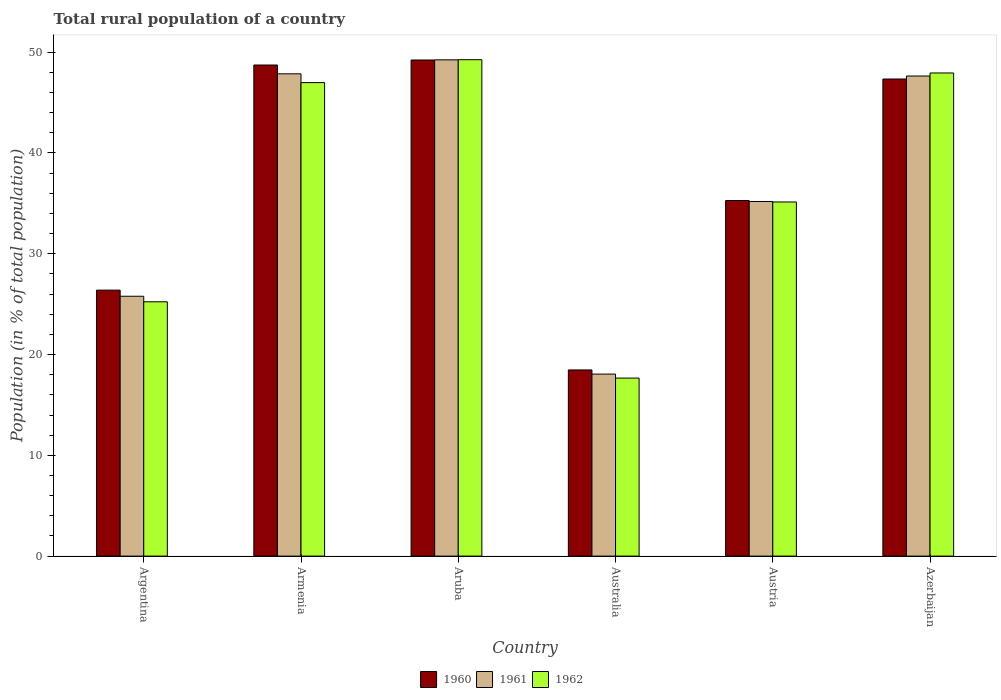How many bars are there on the 3rd tick from the left?
Your answer should be very brief. 3. How many bars are there on the 2nd tick from the right?
Ensure brevity in your answer.  3. What is the label of the 2nd group of bars from the left?
Ensure brevity in your answer.  Armenia. What is the rural population in 1961 in Armenia?
Your answer should be very brief. 47.85. Across all countries, what is the maximum rural population in 1960?
Keep it short and to the point. 49.22. Across all countries, what is the minimum rural population in 1960?
Your response must be concise. 18.47. In which country was the rural population in 1962 maximum?
Your response must be concise. Aruba. In which country was the rural population in 1960 minimum?
Give a very brief answer. Australia. What is the total rural population in 1960 in the graph?
Give a very brief answer. 225.43. What is the difference between the rural population in 1960 in Argentina and that in Australia?
Provide a short and direct response. 7.92. What is the difference between the rural population in 1962 in Argentina and the rural population in 1961 in Aruba?
Offer a very short reply. -24.01. What is the average rural population in 1962 per country?
Your answer should be very brief. 37.03. What is the difference between the rural population of/in 1962 and rural population of/in 1961 in Aruba?
Offer a terse response. 0.02. What is the ratio of the rural population in 1962 in Armenia to that in Australia?
Give a very brief answer. 2.66. Is the difference between the rural population in 1962 in Armenia and Austria greater than the difference between the rural population in 1961 in Armenia and Austria?
Provide a succinct answer. No. What is the difference between the highest and the second highest rural population in 1961?
Provide a succinct answer. 1.6. What is the difference between the highest and the lowest rural population in 1962?
Offer a terse response. 31.59. In how many countries, is the rural population in 1960 greater than the average rural population in 1960 taken over all countries?
Ensure brevity in your answer.  3. What does the 2nd bar from the left in Austria represents?
Your response must be concise. 1961. Is it the case that in every country, the sum of the rural population in 1960 and rural population in 1961 is greater than the rural population in 1962?
Keep it short and to the point. Yes. How many bars are there?
Make the answer very short. 18. Are all the bars in the graph horizontal?
Your answer should be compact. No. Does the graph contain grids?
Provide a succinct answer. No. Where does the legend appear in the graph?
Ensure brevity in your answer.  Bottom center. What is the title of the graph?
Your response must be concise. Total rural population of a country. Does "1972" appear as one of the legend labels in the graph?
Your response must be concise. No. What is the label or title of the X-axis?
Provide a short and direct response. Country. What is the label or title of the Y-axis?
Your answer should be compact. Population (in % of total population). What is the Population (in % of total population) of 1960 in Argentina?
Make the answer very short. 26.39. What is the Population (in % of total population) of 1961 in Argentina?
Offer a very short reply. 25.78. What is the Population (in % of total population) in 1962 in Argentina?
Your response must be concise. 25.23. What is the Population (in % of total population) of 1960 in Armenia?
Provide a short and direct response. 48.73. What is the Population (in % of total population) of 1961 in Armenia?
Your response must be concise. 47.85. What is the Population (in % of total population) of 1962 in Armenia?
Offer a very short reply. 46.98. What is the Population (in % of total population) of 1960 in Aruba?
Provide a short and direct response. 49.22. What is the Population (in % of total population) in 1961 in Aruba?
Ensure brevity in your answer.  49.24. What is the Population (in % of total population) of 1962 in Aruba?
Give a very brief answer. 49.25. What is the Population (in % of total population) in 1960 in Australia?
Give a very brief answer. 18.47. What is the Population (in % of total population) of 1961 in Australia?
Offer a terse response. 18.06. What is the Population (in % of total population) in 1962 in Australia?
Your response must be concise. 17.66. What is the Population (in % of total population) in 1960 in Austria?
Your response must be concise. 35.28. What is the Population (in % of total population) in 1961 in Austria?
Your response must be concise. 35.19. What is the Population (in % of total population) of 1962 in Austria?
Provide a short and direct response. 35.14. What is the Population (in % of total population) of 1960 in Azerbaijan?
Offer a terse response. 47.34. What is the Population (in % of total population) in 1961 in Azerbaijan?
Offer a very short reply. 47.64. What is the Population (in % of total population) of 1962 in Azerbaijan?
Keep it short and to the point. 47.94. Across all countries, what is the maximum Population (in % of total population) of 1960?
Your answer should be very brief. 49.22. Across all countries, what is the maximum Population (in % of total population) of 1961?
Offer a terse response. 49.24. Across all countries, what is the maximum Population (in % of total population) in 1962?
Provide a short and direct response. 49.25. Across all countries, what is the minimum Population (in % of total population) in 1960?
Offer a very short reply. 18.47. Across all countries, what is the minimum Population (in % of total population) in 1961?
Your response must be concise. 18.06. Across all countries, what is the minimum Population (in % of total population) of 1962?
Provide a short and direct response. 17.66. What is the total Population (in % of total population) of 1960 in the graph?
Offer a terse response. 225.43. What is the total Population (in % of total population) of 1961 in the graph?
Make the answer very short. 223.76. What is the total Population (in % of total population) of 1962 in the graph?
Your response must be concise. 222.2. What is the difference between the Population (in % of total population) of 1960 in Argentina and that in Armenia?
Your answer should be compact. -22.34. What is the difference between the Population (in % of total population) of 1961 in Argentina and that in Armenia?
Provide a short and direct response. -22.07. What is the difference between the Population (in % of total population) in 1962 in Argentina and that in Armenia?
Provide a short and direct response. -21.75. What is the difference between the Population (in % of total population) in 1960 in Argentina and that in Aruba?
Your response must be concise. -22.84. What is the difference between the Population (in % of total population) of 1961 in Argentina and that in Aruba?
Your response must be concise. -23.46. What is the difference between the Population (in % of total population) in 1962 in Argentina and that in Aruba?
Offer a terse response. -24.02. What is the difference between the Population (in % of total population) in 1960 in Argentina and that in Australia?
Ensure brevity in your answer.  7.92. What is the difference between the Population (in % of total population) in 1961 in Argentina and that in Australia?
Give a very brief answer. 7.72. What is the difference between the Population (in % of total population) in 1962 in Argentina and that in Australia?
Offer a terse response. 7.57. What is the difference between the Population (in % of total population) in 1960 in Argentina and that in Austria?
Give a very brief answer. -8.89. What is the difference between the Population (in % of total population) of 1961 in Argentina and that in Austria?
Ensure brevity in your answer.  -9.4. What is the difference between the Population (in % of total population) of 1962 in Argentina and that in Austria?
Make the answer very short. -9.9. What is the difference between the Population (in % of total population) of 1960 in Argentina and that in Azerbaijan?
Your response must be concise. -20.95. What is the difference between the Population (in % of total population) in 1961 in Argentina and that in Azerbaijan?
Give a very brief answer. -21.85. What is the difference between the Population (in % of total population) of 1962 in Argentina and that in Azerbaijan?
Your answer should be very brief. -22.7. What is the difference between the Population (in % of total population) in 1960 in Armenia and that in Aruba?
Offer a terse response. -0.5. What is the difference between the Population (in % of total population) of 1961 in Armenia and that in Aruba?
Your answer should be compact. -1.39. What is the difference between the Population (in % of total population) of 1962 in Armenia and that in Aruba?
Your answer should be compact. -2.27. What is the difference between the Population (in % of total population) in 1960 in Armenia and that in Australia?
Offer a terse response. 30.25. What is the difference between the Population (in % of total population) of 1961 in Armenia and that in Australia?
Offer a terse response. 29.79. What is the difference between the Population (in % of total population) in 1962 in Armenia and that in Australia?
Make the answer very short. 29.32. What is the difference between the Population (in % of total population) of 1960 in Armenia and that in Austria?
Your answer should be compact. 13.45. What is the difference between the Population (in % of total population) of 1961 in Armenia and that in Austria?
Your response must be concise. 12.67. What is the difference between the Population (in % of total population) in 1962 in Armenia and that in Austria?
Give a very brief answer. 11.84. What is the difference between the Population (in % of total population) in 1960 in Armenia and that in Azerbaijan?
Your answer should be compact. 1.39. What is the difference between the Population (in % of total population) of 1961 in Armenia and that in Azerbaijan?
Keep it short and to the point. 0.22. What is the difference between the Population (in % of total population) of 1962 in Armenia and that in Azerbaijan?
Ensure brevity in your answer.  -0.95. What is the difference between the Population (in % of total population) of 1960 in Aruba and that in Australia?
Your answer should be very brief. 30.75. What is the difference between the Population (in % of total population) in 1961 in Aruba and that in Australia?
Ensure brevity in your answer.  31.18. What is the difference between the Population (in % of total population) in 1962 in Aruba and that in Australia?
Give a very brief answer. 31.59. What is the difference between the Population (in % of total population) in 1960 in Aruba and that in Austria?
Your response must be concise. 13.94. What is the difference between the Population (in % of total population) of 1961 in Aruba and that in Austria?
Provide a short and direct response. 14.05. What is the difference between the Population (in % of total population) in 1962 in Aruba and that in Austria?
Provide a short and direct response. 14.12. What is the difference between the Population (in % of total population) of 1960 in Aruba and that in Azerbaijan?
Make the answer very short. 1.89. What is the difference between the Population (in % of total population) in 1961 in Aruba and that in Azerbaijan?
Keep it short and to the point. 1.6. What is the difference between the Population (in % of total population) in 1962 in Aruba and that in Azerbaijan?
Ensure brevity in your answer.  1.32. What is the difference between the Population (in % of total population) of 1960 in Australia and that in Austria?
Make the answer very short. -16.81. What is the difference between the Population (in % of total population) of 1961 in Australia and that in Austria?
Give a very brief answer. -17.13. What is the difference between the Population (in % of total population) in 1962 in Australia and that in Austria?
Provide a short and direct response. -17.47. What is the difference between the Population (in % of total population) of 1960 in Australia and that in Azerbaijan?
Your response must be concise. -28.87. What is the difference between the Population (in % of total population) of 1961 in Australia and that in Azerbaijan?
Your answer should be very brief. -29.58. What is the difference between the Population (in % of total population) in 1962 in Australia and that in Azerbaijan?
Ensure brevity in your answer.  -30.27. What is the difference between the Population (in % of total population) in 1960 in Austria and that in Azerbaijan?
Keep it short and to the point. -12.06. What is the difference between the Population (in % of total population) of 1961 in Austria and that in Azerbaijan?
Offer a terse response. -12.45. What is the difference between the Population (in % of total population) in 1962 in Austria and that in Azerbaijan?
Offer a terse response. -12.8. What is the difference between the Population (in % of total population) in 1960 in Argentina and the Population (in % of total population) in 1961 in Armenia?
Your answer should be compact. -21.46. What is the difference between the Population (in % of total population) of 1960 in Argentina and the Population (in % of total population) of 1962 in Armenia?
Your answer should be compact. -20.59. What is the difference between the Population (in % of total population) in 1961 in Argentina and the Population (in % of total population) in 1962 in Armenia?
Ensure brevity in your answer.  -21.2. What is the difference between the Population (in % of total population) in 1960 in Argentina and the Population (in % of total population) in 1961 in Aruba?
Ensure brevity in your answer.  -22.85. What is the difference between the Population (in % of total population) in 1960 in Argentina and the Population (in % of total population) in 1962 in Aruba?
Offer a very short reply. -22.86. What is the difference between the Population (in % of total population) in 1961 in Argentina and the Population (in % of total population) in 1962 in Aruba?
Ensure brevity in your answer.  -23.47. What is the difference between the Population (in % of total population) of 1960 in Argentina and the Population (in % of total population) of 1961 in Australia?
Keep it short and to the point. 8.33. What is the difference between the Population (in % of total population) of 1960 in Argentina and the Population (in % of total population) of 1962 in Australia?
Ensure brevity in your answer.  8.73. What is the difference between the Population (in % of total population) in 1961 in Argentina and the Population (in % of total population) in 1962 in Australia?
Your answer should be very brief. 8.12. What is the difference between the Population (in % of total population) of 1960 in Argentina and the Population (in % of total population) of 1961 in Austria?
Your answer should be compact. -8.8. What is the difference between the Population (in % of total population) of 1960 in Argentina and the Population (in % of total population) of 1962 in Austria?
Your answer should be very brief. -8.75. What is the difference between the Population (in % of total population) in 1961 in Argentina and the Population (in % of total population) in 1962 in Austria?
Make the answer very short. -9.35. What is the difference between the Population (in % of total population) in 1960 in Argentina and the Population (in % of total population) in 1961 in Azerbaijan?
Make the answer very short. -21.25. What is the difference between the Population (in % of total population) of 1960 in Argentina and the Population (in % of total population) of 1962 in Azerbaijan?
Give a very brief answer. -21.55. What is the difference between the Population (in % of total population) in 1961 in Argentina and the Population (in % of total population) in 1962 in Azerbaijan?
Your answer should be very brief. -22.15. What is the difference between the Population (in % of total population) in 1960 in Armenia and the Population (in % of total population) in 1961 in Aruba?
Provide a succinct answer. -0.51. What is the difference between the Population (in % of total population) in 1960 in Armenia and the Population (in % of total population) in 1962 in Aruba?
Your response must be concise. -0.53. What is the difference between the Population (in % of total population) of 1961 in Armenia and the Population (in % of total population) of 1962 in Aruba?
Keep it short and to the point. -1.4. What is the difference between the Population (in % of total population) of 1960 in Armenia and the Population (in % of total population) of 1961 in Australia?
Provide a short and direct response. 30.67. What is the difference between the Population (in % of total population) in 1960 in Armenia and the Population (in % of total population) in 1962 in Australia?
Offer a very short reply. 31.06. What is the difference between the Population (in % of total population) of 1961 in Armenia and the Population (in % of total population) of 1962 in Australia?
Provide a short and direct response. 30.19. What is the difference between the Population (in % of total population) of 1960 in Armenia and the Population (in % of total population) of 1961 in Austria?
Your answer should be compact. 13.54. What is the difference between the Population (in % of total population) in 1960 in Armenia and the Population (in % of total population) in 1962 in Austria?
Give a very brief answer. 13.59. What is the difference between the Population (in % of total population) in 1961 in Armenia and the Population (in % of total population) in 1962 in Austria?
Your response must be concise. 12.72. What is the difference between the Population (in % of total population) of 1960 in Armenia and the Population (in % of total population) of 1961 in Azerbaijan?
Your answer should be compact. 1.09. What is the difference between the Population (in % of total population) of 1960 in Armenia and the Population (in % of total population) of 1962 in Azerbaijan?
Make the answer very short. 0.79. What is the difference between the Population (in % of total population) in 1961 in Armenia and the Population (in % of total population) in 1962 in Azerbaijan?
Provide a short and direct response. -0.08. What is the difference between the Population (in % of total population) in 1960 in Aruba and the Population (in % of total population) in 1961 in Australia?
Offer a terse response. 31.16. What is the difference between the Population (in % of total population) in 1960 in Aruba and the Population (in % of total population) in 1962 in Australia?
Provide a succinct answer. 31.56. What is the difference between the Population (in % of total population) of 1961 in Aruba and the Population (in % of total population) of 1962 in Australia?
Offer a terse response. 31.58. What is the difference between the Population (in % of total population) of 1960 in Aruba and the Population (in % of total population) of 1961 in Austria?
Your answer should be compact. 14.04. What is the difference between the Population (in % of total population) of 1960 in Aruba and the Population (in % of total population) of 1962 in Austria?
Your response must be concise. 14.09. What is the difference between the Population (in % of total population) of 1961 in Aruba and the Population (in % of total population) of 1962 in Austria?
Provide a succinct answer. 14.1. What is the difference between the Population (in % of total population) in 1960 in Aruba and the Population (in % of total population) in 1961 in Azerbaijan?
Offer a terse response. 1.59. What is the difference between the Population (in % of total population) in 1960 in Aruba and the Population (in % of total population) in 1962 in Azerbaijan?
Give a very brief answer. 1.29. What is the difference between the Population (in % of total population) of 1961 in Aruba and the Population (in % of total population) of 1962 in Azerbaijan?
Provide a succinct answer. 1.3. What is the difference between the Population (in % of total population) in 1960 in Australia and the Population (in % of total population) in 1961 in Austria?
Offer a terse response. -16.71. What is the difference between the Population (in % of total population) in 1960 in Australia and the Population (in % of total population) in 1962 in Austria?
Your answer should be very brief. -16.67. What is the difference between the Population (in % of total population) of 1961 in Australia and the Population (in % of total population) of 1962 in Austria?
Keep it short and to the point. -17.08. What is the difference between the Population (in % of total population) of 1960 in Australia and the Population (in % of total population) of 1961 in Azerbaijan?
Ensure brevity in your answer.  -29.16. What is the difference between the Population (in % of total population) in 1960 in Australia and the Population (in % of total population) in 1962 in Azerbaijan?
Your answer should be very brief. -29.46. What is the difference between the Population (in % of total population) of 1961 in Australia and the Population (in % of total population) of 1962 in Azerbaijan?
Ensure brevity in your answer.  -29.88. What is the difference between the Population (in % of total population) in 1960 in Austria and the Population (in % of total population) in 1961 in Azerbaijan?
Provide a succinct answer. -12.36. What is the difference between the Population (in % of total population) in 1960 in Austria and the Population (in % of total population) in 1962 in Azerbaijan?
Provide a succinct answer. -12.66. What is the difference between the Population (in % of total population) of 1961 in Austria and the Population (in % of total population) of 1962 in Azerbaijan?
Offer a terse response. -12.75. What is the average Population (in % of total population) of 1960 per country?
Your response must be concise. 37.57. What is the average Population (in % of total population) in 1961 per country?
Offer a very short reply. 37.29. What is the average Population (in % of total population) of 1962 per country?
Your answer should be compact. 37.03. What is the difference between the Population (in % of total population) in 1960 and Population (in % of total population) in 1961 in Argentina?
Provide a short and direct response. 0.61. What is the difference between the Population (in % of total population) in 1960 and Population (in % of total population) in 1962 in Argentina?
Ensure brevity in your answer.  1.16. What is the difference between the Population (in % of total population) in 1961 and Population (in % of total population) in 1962 in Argentina?
Your response must be concise. 0.55. What is the difference between the Population (in % of total population) of 1960 and Population (in % of total population) of 1961 in Armenia?
Give a very brief answer. 0.87. What is the difference between the Population (in % of total population) of 1960 and Population (in % of total population) of 1962 in Armenia?
Give a very brief answer. 1.74. What is the difference between the Population (in % of total population) of 1961 and Population (in % of total population) of 1962 in Armenia?
Give a very brief answer. 0.87. What is the difference between the Population (in % of total population) of 1960 and Population (in % of total population) of 1961 in Aruba?
Provide a short and direct response. -0.01. What is the difference between the Population (in % of total population) of 1960 and Population (in % of total population) of 1962 in Aruba?
Give a very brief answer. -0.03. What is the difference between the Population (in % of total population) of 1961 and Population (in % of total population) of 1962 in Aruba?
Offer a terse response. -0.01. What is the difference between the Population (in % of total population) in 1960 and Population (in % of total population) in 1961 in Australia?
Make the answer very short. 0.41. What is the difference between the Population (in % of total population) of 1960 and Population (in % of total population) of 1962 in Australia?
Keep it short and to the point. 0.81. What is the difference between the Population (in % of total population) of 1961 and Population (in % of total population) of 1962 in Australia?
Make the answer very short. 0.4. What is the difference between the Population (in % of total population) of 1960 and Population (in % of total population) of 1961 in Austria?
Give a very brief answer. 0.09. What is the difference between the Population (in % of total population) of 1960 and Population (in % of total population) of 1962 in Austria?
Provide a succinct answer. 0.14. What is the difference between the Population (in % of total population) in 1961 and Population (in % of total population) in 1962 in Austria?
Offer a very short reply. 0.05. What is the difference between the Population (in % of total population) in 1960 and Population (in % of total population) in 1961 in Azerbaijan?
Offer a terse response. -0.3. What is the difference between the Population (in % of total population) in 1960 and Population (in % of total population) in 1962 in Azerbaijan?
Keep it short and to the point. -0.6. What is the difference between the Population (in % of total population) of 1961 and Population (in % of total population) of 1962 in Azerbaijan?
Ensure brevity in your answer.  -0.3. What is the ratio of the Population (in % of total population) in 1960 in Argentina to that in Armenia?
Ensure brevity in your answer.  0.54. What is the ratio of the Population (in % of total population) in 1961 in Argentina to that in Armenia?
Your answer should be very brief. 0.54. What is the ratio of the Population (in % of total population) in 1962 in Argentina to that in Armenia?
Offer a very short reply. 0.54. What is the ratio of the Population (in % of total population) in 1960 in Argentina to that in Aruba?
Provide a succinct answer. 0.54. What is the ratio of the Population (in % of total population) of 1961 in Argentina to that in Aruba?
Offer a very short reply. 0.52. What is the ratio of the Population (in % of total population) in 1962 in Argentina to that in Aruba?
Your answer should be very brief. 0.51. What is the ratio of the Population (in % of total population) in 1960 in Argentina to that in Australia?
Your answer should be very brief. 1.43. What is the ratio of the Population (in % of total population) of 1961 in Argentina to that in Australia?
Give a very brief answer. 1.43. What is the ratio of the Population (in % of total population) in 1962 in Argentina to that in Australia?
Make the answer very short. 1.43. What is the ratio of the Population (in % of total population) in 1960 in Argentina to that in Austria?
Offer a terse response. 0.75. What is the ratio of the Population (in % of total population) in 1961 in Argentina to that in Austria?
Offer a terse response. 0.73. What is the ratio of the Population (in % of total population) in 1962 in Argentina to that in Austria?
Keep it short and to the point. 0.72. What is the ratio of the Population (in % of total population) in 1960 in Argentina to that in Azerbaijan?
Make the answer very short. 0.56. What is the ratio of the Population (in % of total population) in 1961 in Argentina to that in Azerbaijan?
Keep it short and to the point. 0.54. What is the ratio of the Population (in % of total population) of 1962 in Argentina to that in Azerbaijan?
Offer a very short reply. 0.53. What is the ratio of the Population (in % of total population) in 1960 in Armenia to that in Aruba?
Offer a terse response. 0.99. What is the ratio of the Population (in % of total population) of 1961 in Armenia to that in Aruba?
Provide a succinct answer. 0.97. What is the ratio of the Population (in % of total population) of 1962 in Armenia to that in Aruba?
Your answer should be compact. 0.95. What is the ratio of the Population (in % of total population) in 1960 in Armenia to that in Australia?
Offer a very short reply. 2.64. What is the ratio of the Population (in % of total population) of 1961 in Armenia to that in Australia?
Offer a very short reply. 2.65. What is the ratio of the Population (in % of total population) of 1962 in Armenia to that in Australia?
Your response must be concise. 2.66. What is the ratio of the Population (in % of total population) of 1960 in Armenia to that in Austria?
Make the answer very short. 1.38. What is the ratio of the Population (in % of total population) in 1961 in Armenia to that in Austria?
Give a very brief answer. 1.36. What is the ratio of the Population (in % of total population) in 1962 in Armenia to that in Austria?
Give a very brief answer. 1.34. What is the ratio of the Population (in % of total population) of 1960 in Armenia to that in Azerbaijan?
Offer a very short reply. 1.03. What is the ratio of the Population (in % of total population) of 1961 in Armenia to that in Azerbaijan?
Provide a succinct answer. 1. What is the ratio of the Population (in % of total population) in 1962 in Armenia to that in Azerbaijan?
Give a very brief answer. 0.98. What is the ratio of the Population (in % of total population) in 1960 in Aruba to that in Australia?
Your response must be concise. 2.66. What is the ratio of the Population (in % of total population) in 1961 in Aruba to that in Australia?
Provide a short and direct response. 2.73. What is the ratio of the Population (in % of total population) in 1962 in Aruba to that in Australia?
Offer a terse response. 2.79. What is the ratio of the Population (in % of total population) of 1960 in Aruba to that in Austria?
Make the answer very short. 1.4. What is the ratio of the Population (in % of total population) in 1961 in Aruba to that in Austria?
Provide a short and direct response. 1.4. What is the ratio of the Population (in % of total population) of 1962 in Aruba to that in Austria?
Give a very brief answer. 1.4. What is the ratio of the Population (in % of total population) in 1960 in Aruba to that in Azerbaijan?
Offer a very short reply. 1.04. What is the ratio of the Population (in % of total population) in 1961 in Aruba to that in Azerbaijan?
Your answer should be very brief. 1.03. What is the ratio of the Population (in % of total population) of 1962 in Aruba to that in Azerbaijan?
Offer a very short reply. 1.03. What is the ratio of the Population (in % of total population) in 1960 in Australia to that in Austria?
Offer a very short reply. 0.52. What is the ratio of the Population (in % of total population) in 1961 in Australia to that in Austria?
Your answer should be very brief. 0.51. What is the ratio of the Population (in % of total population) of 1962 in Australia to that in Austria?
Ensure brevity in your answer.  0.5. What is the ratio of the Population (in % of total population) of 1960 in Australia to that in Azerbaijan?
Keep it short and to the point. 0.39. What is the ratio of the Population (in % of total population) in 1961 in Australia to that in Azerbaijan?
Your response must be concise. 0.38. What is the ratio of the Population (in % of total population) in 1962 in Australia to that in Azerbaijan?
Give a very brief answer. 0.37. What is the ratio of the Population (in % of total population) in 1960 in Austria to that in Azerbaijan?
Keep it short and to the point. 0.75. What is the ratio of the Population (in % of total population) of 1961 in Austria to that in Azerbaijan?
Keep it short and to the point. 0.74. What is the ratio of the Population (in % of total population) in 1962 in Austria to that in Azerbaijan?
Provide a short and direct response. 0.73. What is the difference between the highest and the second highest Population (in % of total population) in 1960?
Give a very brief answer. 0.5. What is the difference between the highest and the second highest Population (in % of total population) in 1961?
Make the answer very short. 1.39. What is the difference between the highest and the second highest Population (in % of total population) of 1962?
Keep it short and to the point. 1.32. What is the difference between the highest and the lowest Population (in % of total population) of 1960?
Offer a very short reply. 30.75. What is the difference between the highest and the lowest Population (in % of total population) of 1961?
Ensure brevity in your answer.  31.18. What is the difference between the highest and the lowest Population (in % of total population) in 1962?
Your response must be concise. 31.59. 